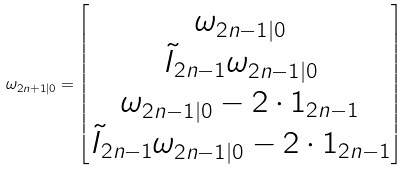<formula> <loc_0><loc_0><loc_500><loc_500>\omega _ { 2 n + 1 | 0 } = \begin{bmatrix} \omega _ { 2 n - 1 | 0 } \\ \tilde { I } _ { 2 n - 1 } \omega _ { 2 n - 1 | 0 } \\ \omega _ { 2 n - 1 | 0 } - 2 \cdot 1 _ { 2 n - 1 } \\ \tilde { I } _ { 2 n - 1 } \omega _ { 2 n - 1 | 0 } - 2 \cdot 1 _ { 2 n - 1 } \end{bmatrix}</formula> 